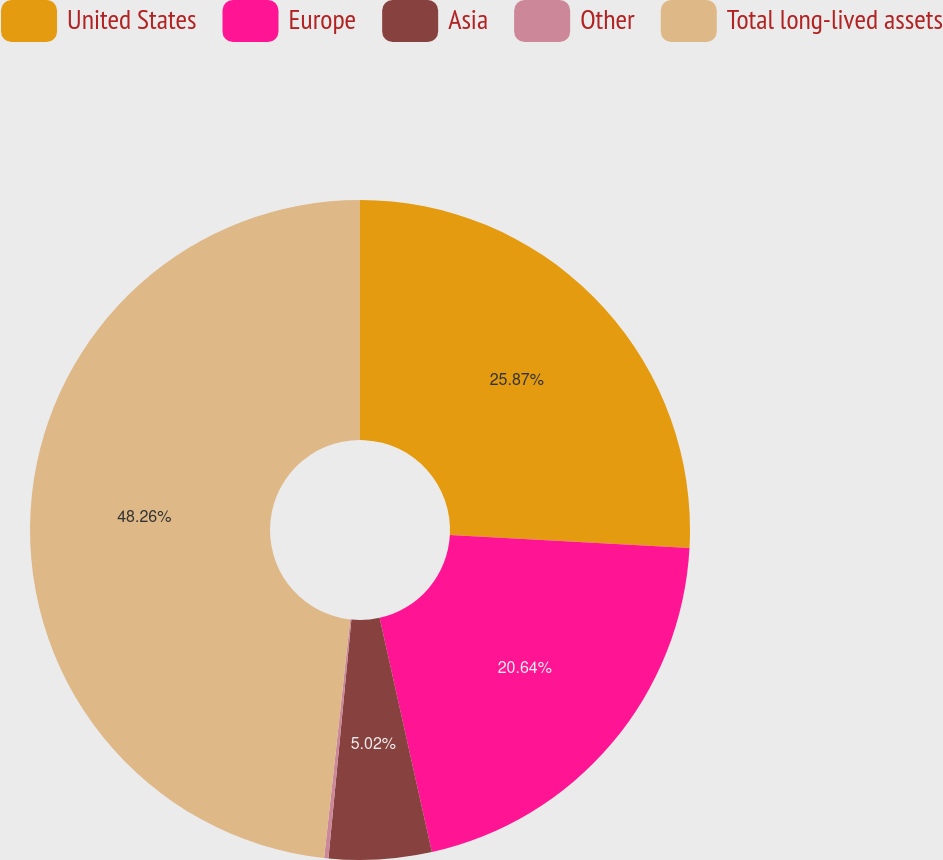Convert chart. <chart><loc_0><loc_0><loc_500><loc_500><pie_chart><fcel>United States<fcel>Europe<fcel>Asia<fcel>Other<fcel>Total long-lived assets<nl><fcel>25.87%<fcel>20.64%<fcel>5.02%<fcel>0.21%<fcel>48.27%<nl></chart> 